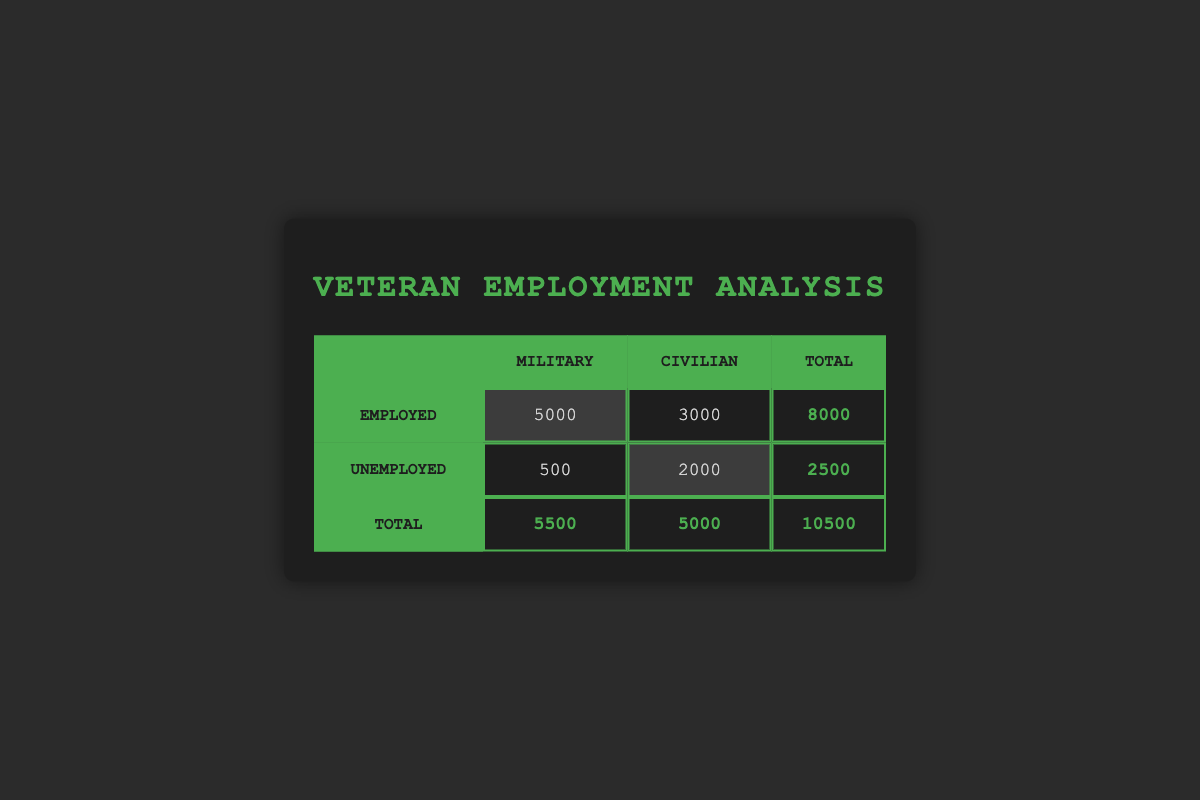What is the total number of veterans employed in the military? The table shows that there are 5000 veterans employed in the military under the "Employed" row and "Military" column.
Answer: 5000 What is the total count of unemployed veterans in civilian roles? The table indicates that there are 2000 unemployed veterans in the civilian sector in the "Unemployed" row and "Civilian" column.
Answer: 2000 How many more veterans are employed in the military than in civilian jobs? To find the difference, subtract the number of employed veterans in civilian jobs (3000) from those in military (5000): 5000 - 3000 = 2000.
Answer: 2000 What is the total number of veterans across all employment types? The total veteran count is the sum of the totals in the last row: 5500 (Military) + 5000 (Civilian) = 10500.
Answer: 10500 Is it true that there are more unemployed veterans in the civilian sector than in the military? Yes, comparing the numbers of unemployed veterans, there are 2000 civilian unemployed vs. 500 military unemployed, confirming that civilian unemployment is greater.
Answer: Yes What percentage of employed veterans work in civilian jobs? To calculate the percentage, divide the number of employed veterans in civilian jobs (3000) by the total employed (8000) and then multiply by 100: (3000/8000) * 100 = 37.5%.
Answer: 37.5% What is the ratio of unemployed veterans in the military to those in civilian roles? The ratio can be determined by dividing the number of unemployed veterans in the military (500) by those in civilian roles (2000): 500/2000 = 1:4.
Answer: 1:4 How many total veterans are either employed or unemployed in the civilian sector? We sum the employed (3000) and unemployed (2000) veterans in civilian roles: 3000 + 2000 = 5000.
Answer: 5000 What is the difference in total employment status between military and civilian veterans? Total military: 5500, total civilian: 5000. The difference is 5500 - 5000 = 500.
Answer: 500 